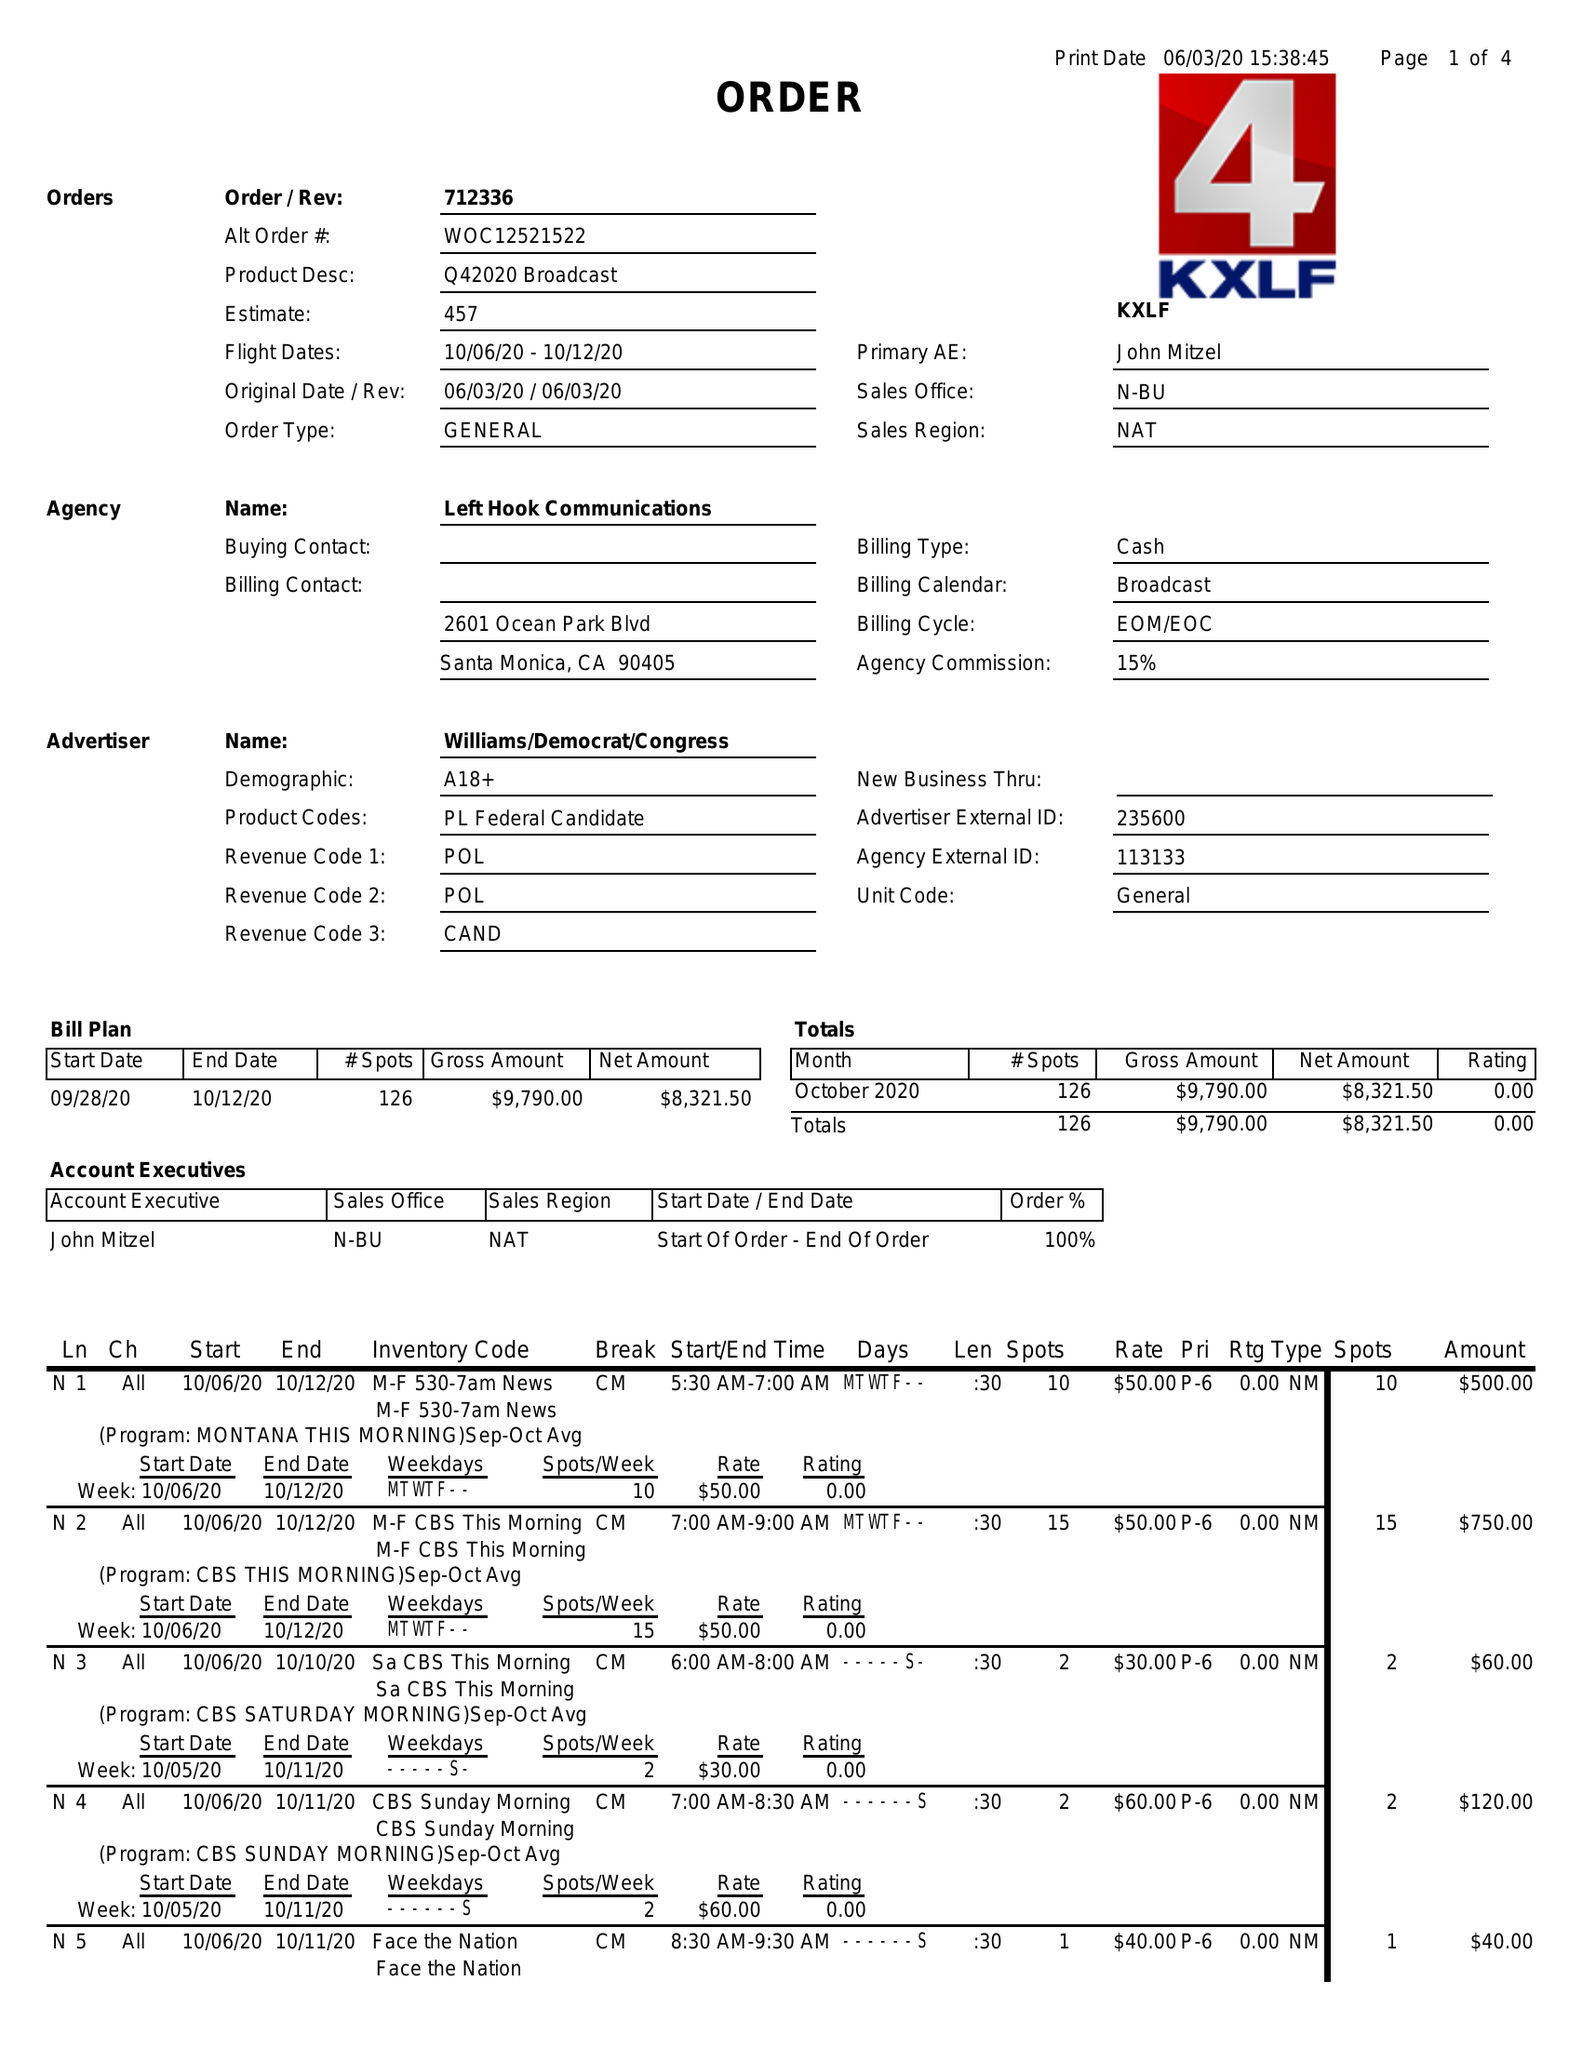What is the value for the gross_amount?
Answer the question using a single word or phrase. 9790.00 